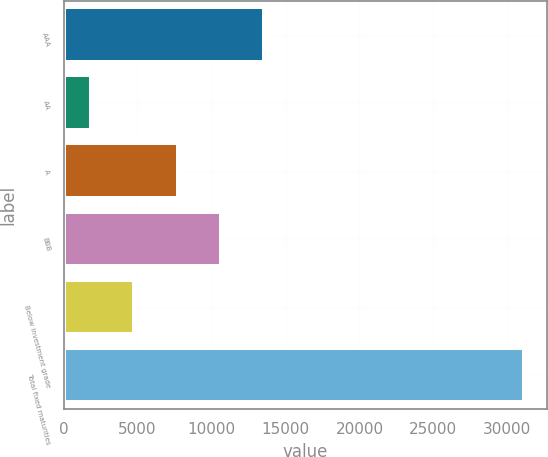<chart> <loc_0><loc_0><loc_500><loc_500><bar_chart><fcel>AAA<fcel>AA<fcel>A<fcel>BBB<fcel>Below investment grade<fcel>Total fixed maturities<nl><fcel>13556.6<fcel>1843<fcel>7699.8<fcel>10628.2<fcel>4771.4<fcel>31127<nl></chart> 